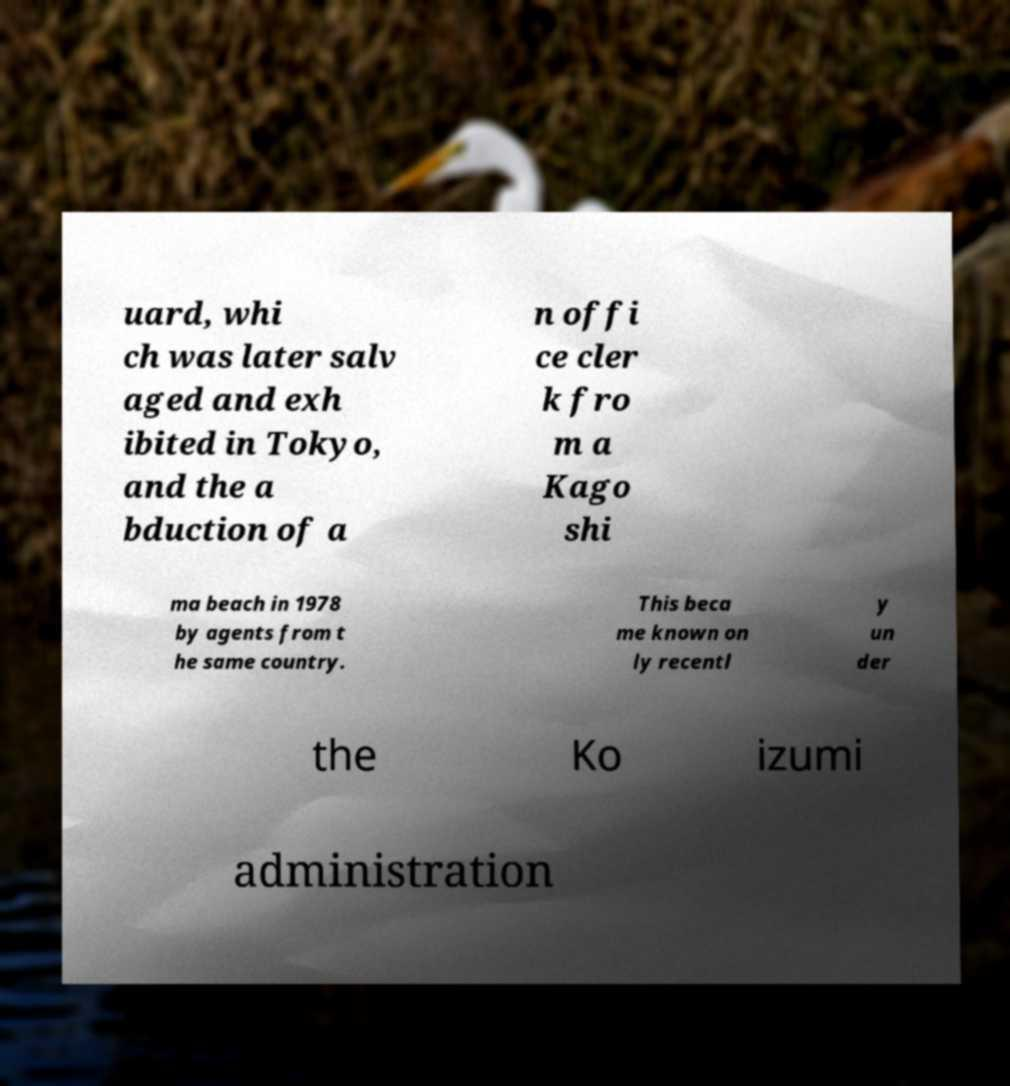Could you assist in decoding the text presented in this image and type it out clearly? uard, whi ch was later salv aged and exh ibited in Tokyo, and the a bduction of a n offi ce cler k fro m a Kago shi ma beach in 1978 by agents from t he same country. This beca me known on ly recentl y un der the Ko izumi administration 